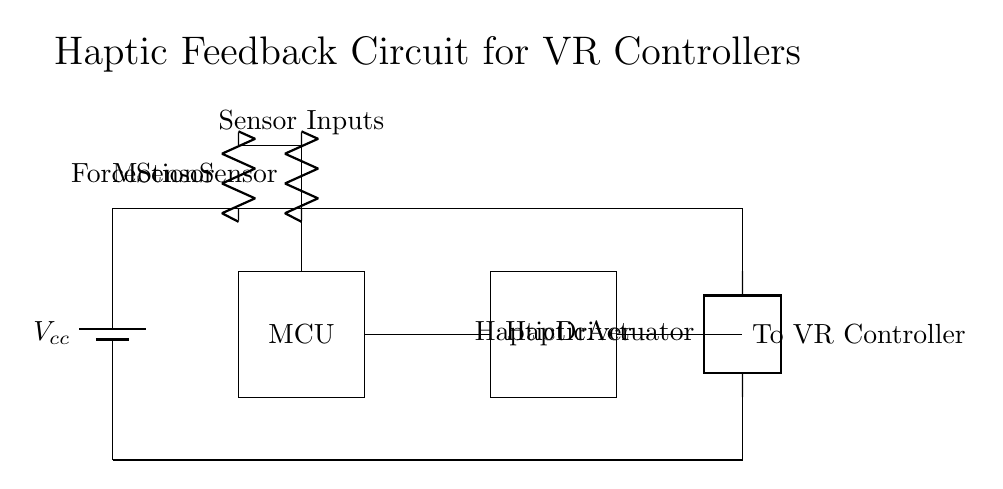What is the power supply voltage labeled in the circuit? The circuit diagram shows a battery labeled as Vcc at the top left corner, which indicates the power supply voltage for the circuit.
Answer: Vcc What component is responsible for translating sensor signals in this circuit? The microcontroller (MCU), located in the middle of the diagram, is typically responsible for processing inputs from the sensors and controlling the output to the haptic driver accordingly.
Answer: MCU How many sensors are present in the circuit? There are two sensors shown: a force sensor and a motion sensor, labeled at the top left of the diagram.
Answer: Two What is the output device connected to the haptic driver? The haptic actuator is the output device connected to the haptic driver, shown at the right end of the circuit diagram.
Answer: Haptic actuator Why is the haptic driver connected to the microcontroller? The haptic driver needs commands from the microcontroller to generate specific feedback patterns, which enhance the immersive experience in virtual reality by coordinating the actuator's movements based on sensor inputs.
Answer: To generate feedback What signals are indicated as inputs to the microcontroller? The circuit shows two signals from the force sensor and the motion sensor, indicating the type of inputs the microcontroller receives for processing.
Answer: Sensor inputs What is the purpose of the circuit in the context of virtual reality applications? The circuit is designed to provide haptic feedback through the haptic actuator, enhancing the immersive experience by simulating touch and sensation based on user interactions in virtual reality environments.
Answer: Haptic feedback 